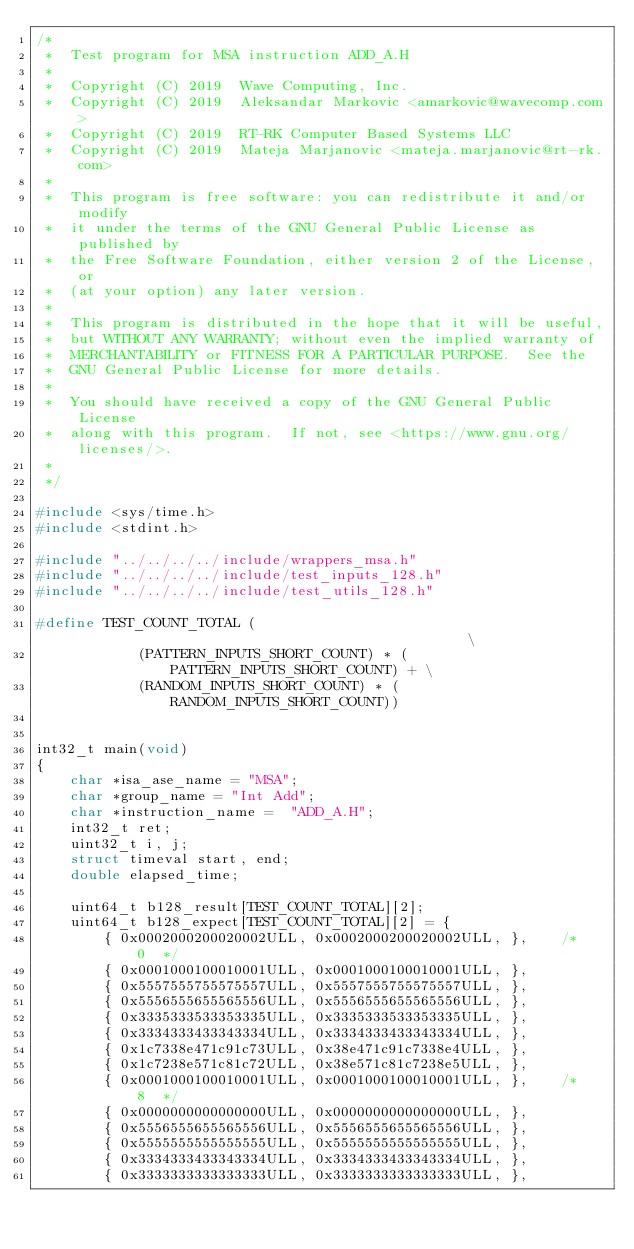<code> <loc_0><loc_0><loc_500><loc_500><_C_>/*
 *  Test program for MSA instruction ADD_A.H
 *
 *  Copyright (C) 2019  Wave Computing, Inc.
 *  Copyright (C) 2019  Aleksandar Markovic <amarkovic@wavecomp.com>
 *  Copyright (C) 2019  RT-RK Computer Based Systems LLC
 *  Copyright (C) 2019  Mateja Marjanovic <mateja.marjanovic@rt-rk.com>
 *
 *  This program is free software: you can redistribute it and/or modify
 *  it under the terms of the GNU General Public License as published by
 *  the Free Software Foundation, either version 2 of the License, or
 *  (at your option) any later version.
 *
 *  This program is distributed in the hope that it will be useful,
 *  but WITHOUT ANY WARRANTY; without even the implied warranty of
 *  MERCHANTABILITY or FITNESS FOR A PARTICULAR PURPOSE.  See the
 *  GNU General Public License for more details.
 *
 *  You should have received a copy of the GNU General Public License
 *  along with this program.  If not, see <https://www.gnu.org/licenses/>.
 *
 */

#include <sys/time.h>
#include <stdint.h>

#include "../../../../include/wrappers_msa.h"
#include "../../../../include/test_inputs_128.h"
#include "../../../../include/test_utils_128.h"

#define TEST_COUNT_TOTAL (                                                \
            (PATTERN_INPUTS_SHORT_COUNT) * (PATTERN_INPUTS_SHORT_COUNT) + \
            (RANDOM_INPUTS_SHORT_COUNT) * (RANDOM_INPUTS_SHORT_COUNT))


int32_t main(void)
{
    char *isa_ase_name = "MSA";
    char *group_name = "Int Add";
    char *instruction_name =  "ADD_A.H";
    int32_t ret;
    uint32_t i, j;
    struct timeval start, end;
    double elapsed_time;

    uint64_t b128_result[TEST_COUNT_TOTAL][2];
    uint64_t b128_expect[TEST_COUNT_TOTAL][2] = {
        { 0x0002000200020002ULL, 0x0002000200020002ULL, },    /*   0  */
        { 0x0001000100010001ULL, 0x0001000100010001ULL, },
        { 0x5557555755575557ULL, 0x5557555755575557ULL, },
        { 0x5556555655565556ULL, 0x5556555655565556ULL, },
        { 0x3335333533353335ULL, 0x3335333533353335ULL, },
        { 0x3334333433343334ULL, 0x3334333433343334ULL, },
        { 0x1c7338e471c91c73ULL, 0x38e471c91c7338e4ULL, },
        { 0x1c7238e571c81c72ULL, 0x38e571c81c7238e5ULL, },
        { 0x0001000100010001ULL, 0x0001000100010001ULL, },    /*   8  */
        { 0x0000000000000000ULL, 0x0000000000000000ULL, },
        { 0x5556555655565556ULL, 0x5556555655565556ULL, },
        { 0x5555555555555555ULL, 0x5555555555555555ULL, },
        { 0x3334333433343334ULL, 0x3334333433343334ULL, },
        { 0x3333333333333333ULL, 0x3333333333333333ULL, },</code> 